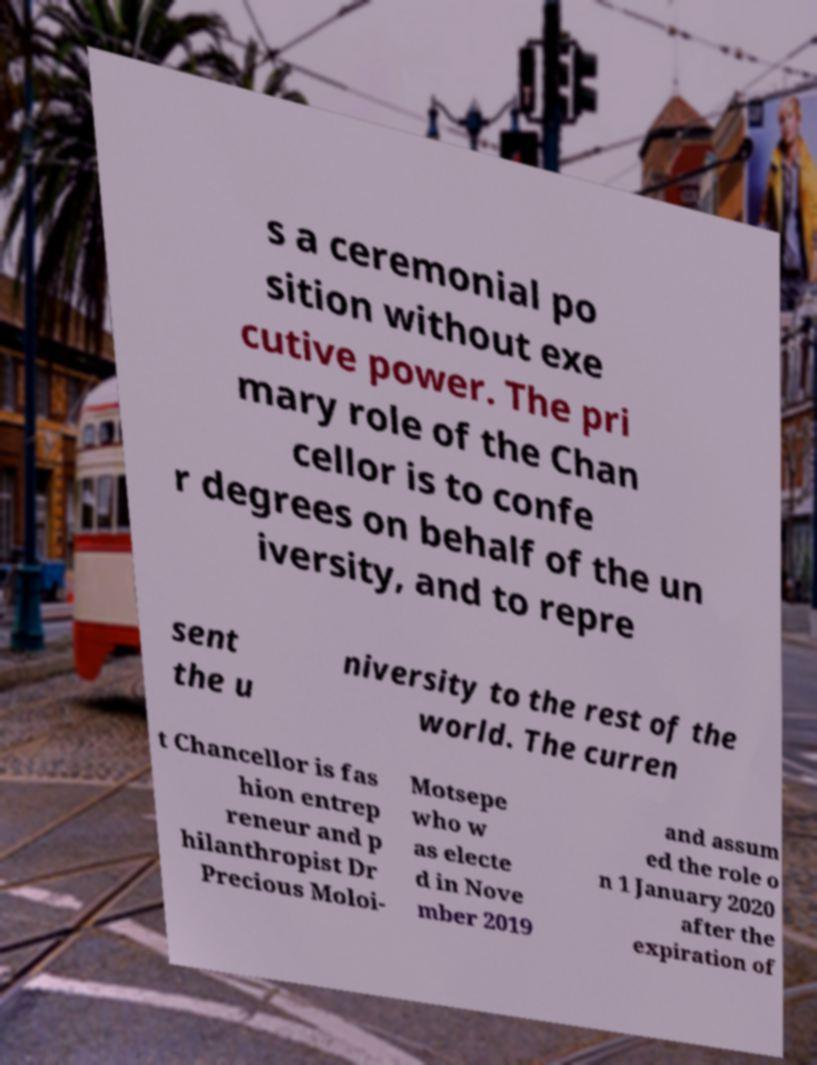Please read and relay the text visible in this image. What does it say? s a ceremonial po sition without exe cutive power. The pri mary role of the Chan cellor is to confe r degrees on behalf of the un iversity, and to repre sent the u niversity to the rest of the world. The curren t Chancellor is fas hion entrep reneur and p hilanthropist Dr Precious Moloi- Motsepe who w as electe d in Nove mber 2019 and assum ed the role o n 1 January 2020 after the expiration of 